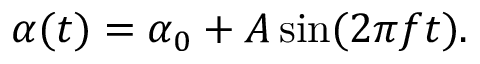Convert formula to latex. <formula><loc_0><loc_0><loc_500><loc_500>\alpha ( t ) = \alpha _ { 0 } + A \sin ( 2 \pi f t ) .</formula> 